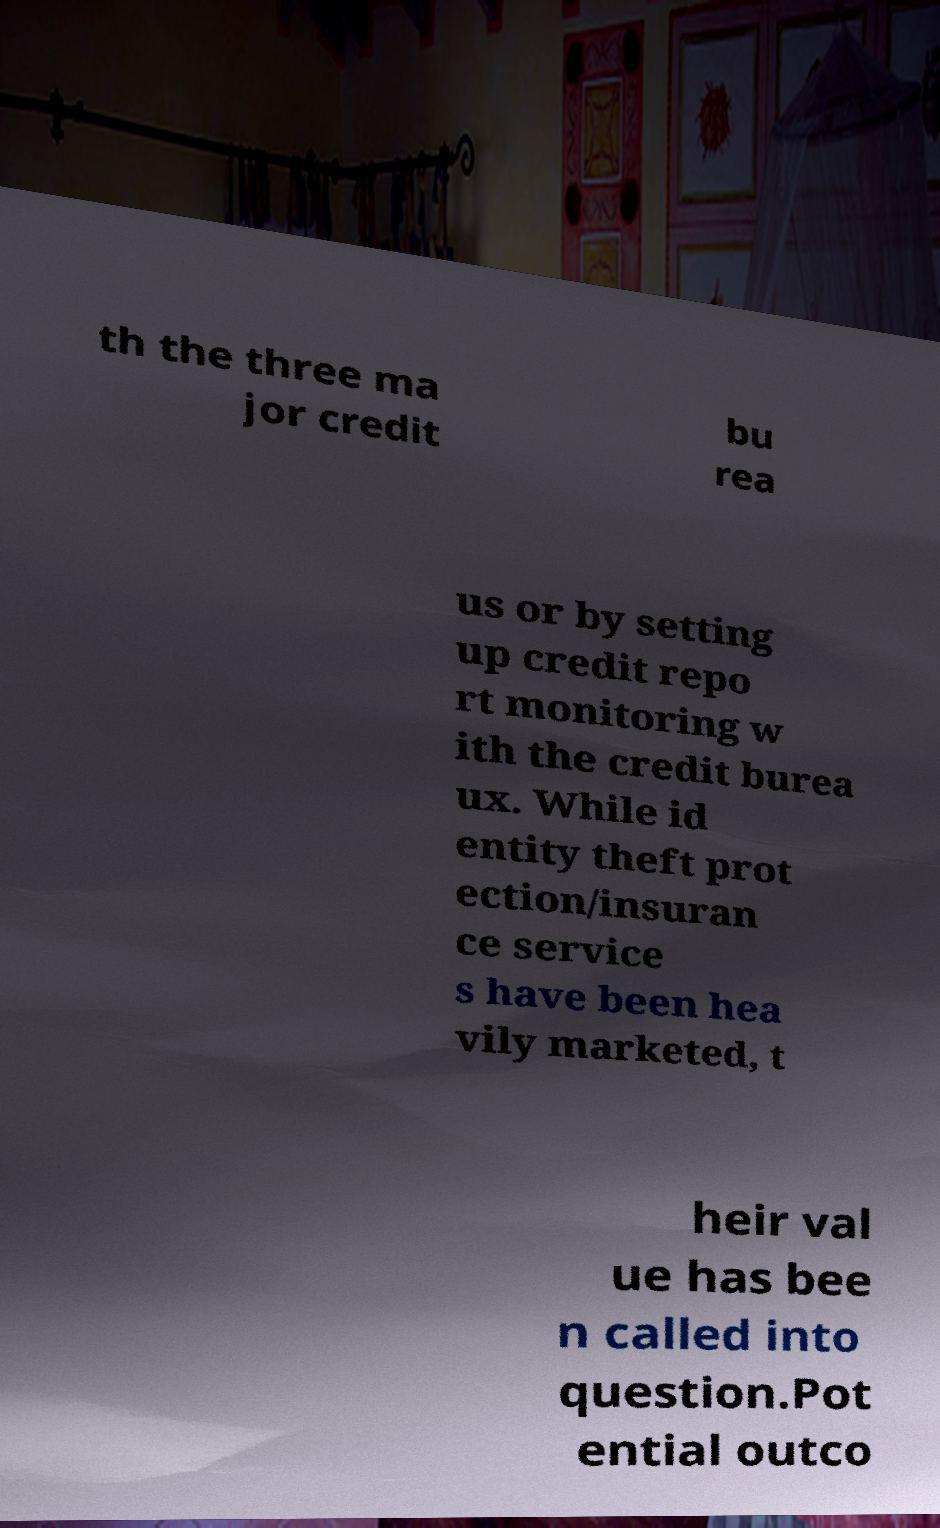Please identify and transcribe the text found in this image. th the three ma jor credit bu rea us or by setting up credit repo rt monitoring w ith the credit burea ux. While id entity theft prot ection/insuran ce service s have been hea vily marketed, t heir val ue has bee n called into question.Pot ential outco 